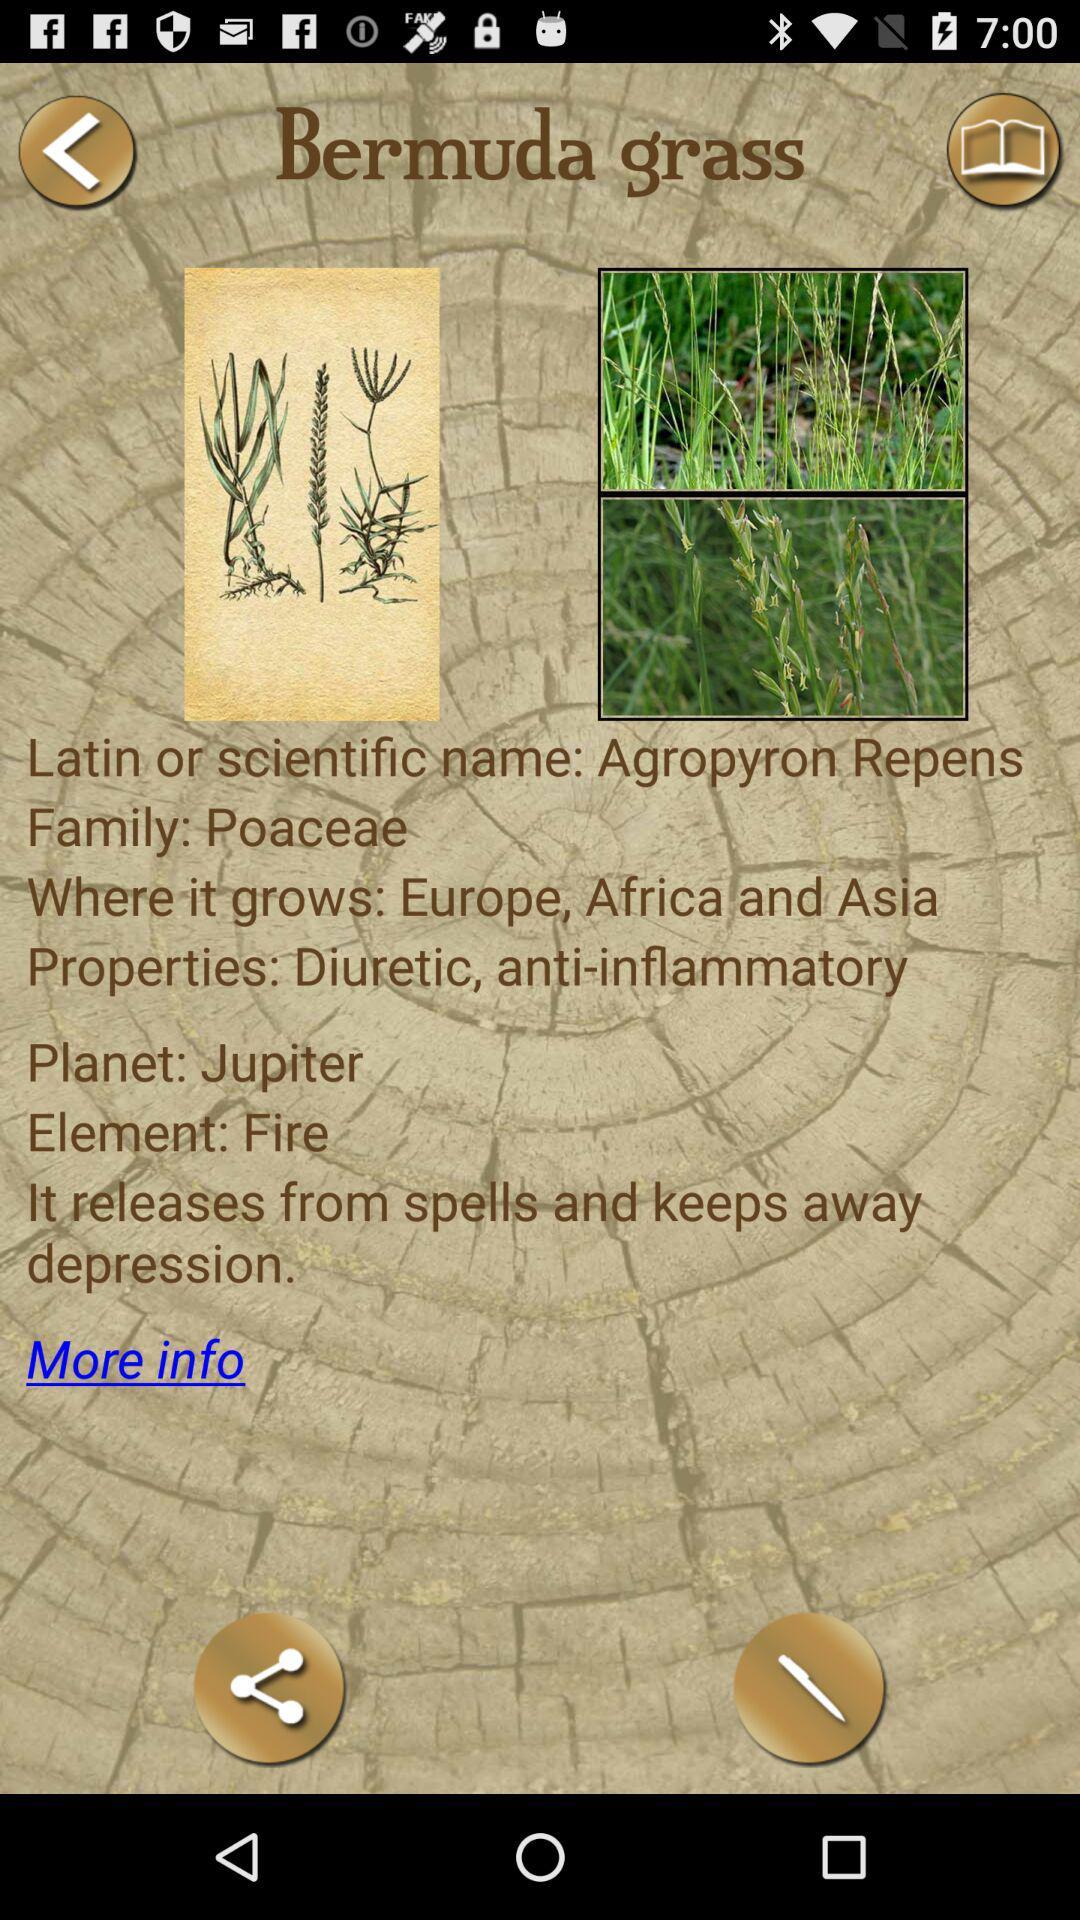What is the family of Bermuda grass? The family of Bermuda grass is "Poaceae". 